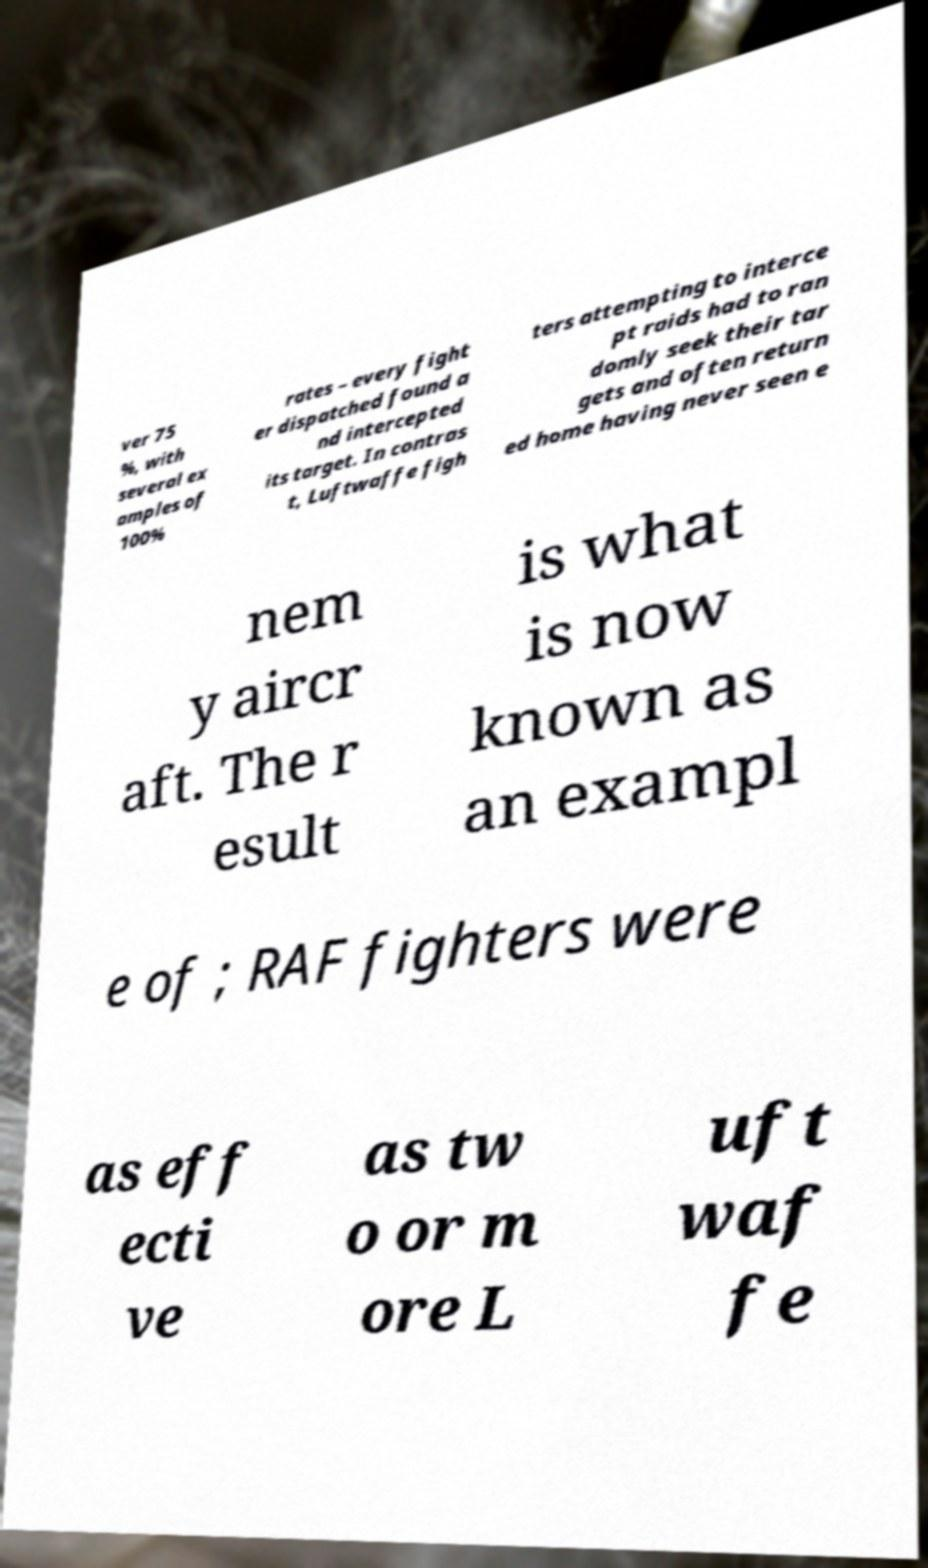There's text embedded in this image that I need extracted. Can you transcribe it verbatim? ver 75 %, with several ex amples of 100% rates – every fight er dispatched found a nd intercepted its target. In contras t, Luftwaffe figh ters attempting to interce pt raids had to ran domly seek their tar gets and often return ed home having never seen e nem y aircr aft. The r esult is what is now known as an exampl e of ; RAF fighters were as eff ecti ve as tw o or m ore L uft waf fe 